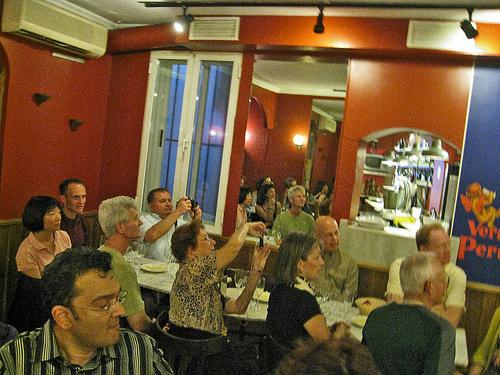Identify the person holding a cell phone and describe their appearance. A woman is holding a cell phone, she has short hair and is possibly wearing a black shirt. Are there any architectural features in the image, if so what are they? Yes, there is an archway leading to the next room and two windows providing a view to the outside. Count the total number of people in the image and mention their genders. There are nine people in the image, five men and four women. Explain where the light sources are in the image and their types. There is a light mounted to the ceiling, black lights on the ceiling, and a light on the wall. Describe the hair color and style of the men and women in the image. There's a man with no hair, a man with grey hair, a woman with short hair, a woman with black hair, and a person with a black sideburn. What is unique about the man wearing glasses? The man wearing glasses is the only person in the image whose eyewear is specifically mentioned. What is the primary activity taking place in the image? People seem to be interacting and engaging in different activities like taking photos, looking at objects, and talking. Describe any decorative elements or objects of interest in the image. There is an angel in a picture, a large mirror on the wall, and a white plate on a table. Find an event in the image involving a man and a camera. A man holding a camera Identify the object found at the intersection of two rooms. A counter What is the composition of the archway to the next room? 353x124 position and 104x104 size How many males with cameras can be seen in the image? Two males, one holding a camera and another identified as a man with a camera Is there a cat sitting on the counter in the middle of the two rooms? No, it's not mentioned in the image. What type of hair does the woman in the image have? Short hair Which of the following objects are present in the image - a light mounted to the ceiling, a person wearing eyeglasses, a car parked on the street? A light mounted to the ceiling, a person wearing eyeglasses What is the woman in the image doing? Holding a cell phone What color is the paint on the wall in one of the rooms? Orange What kind of activities can be seen in the image? Lady taking a photo, man holding a camera What facial features can be identified in the image? A person with a black sideburn, the ear of a person Find a non-human object in the image that could be used for ventilation. A white air vent cover What is on the table in the image? A white plate Who is wearing a green shirt in the image? A person, with an unclear gender What are the features of the large mirror on the wall? Positioned at 251x50 and has a size of 212x212 Describe the windows present in the image. Two windows for the outside, with glass panes and a size of 77x77 Is there any supernatural being present in the image? Angel on the picture Identify any objects related to ceiling decor in the image. A light mounted to the ceiling, black lights on the ceiling Is there a bald person in the image? Yes, a man with a bald head can be seen. 